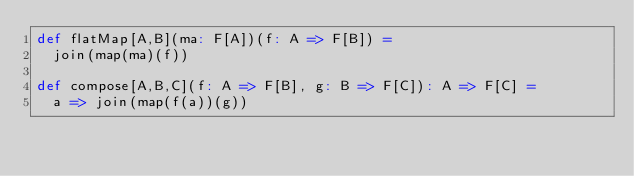<code> <loc_0><loc_0><loc_500><loc_500><_Scala_>def flatMap[A,B](ma: F[A])(f: A => F[B]) =
  join(map(ma)(f))

def compose[A,B,C](f: A => F[B], g: B => F[C]): A => F[C] =
  a => join(map(f(a))(g))
</code> 